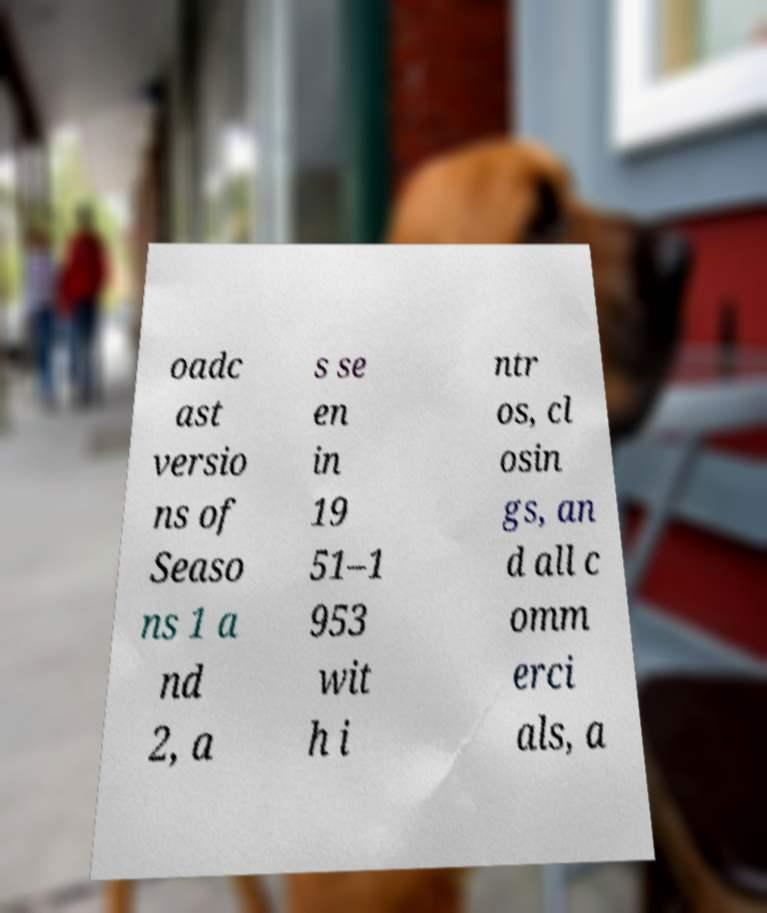I need the written content from this picture converted into text. Can you do that? oadc ast versio ns of Seaso ns 1 a nd 2, a s se en in 19 51–1 953 wit h i ntr os, cl osin gs, an d all c omm erci als, a 